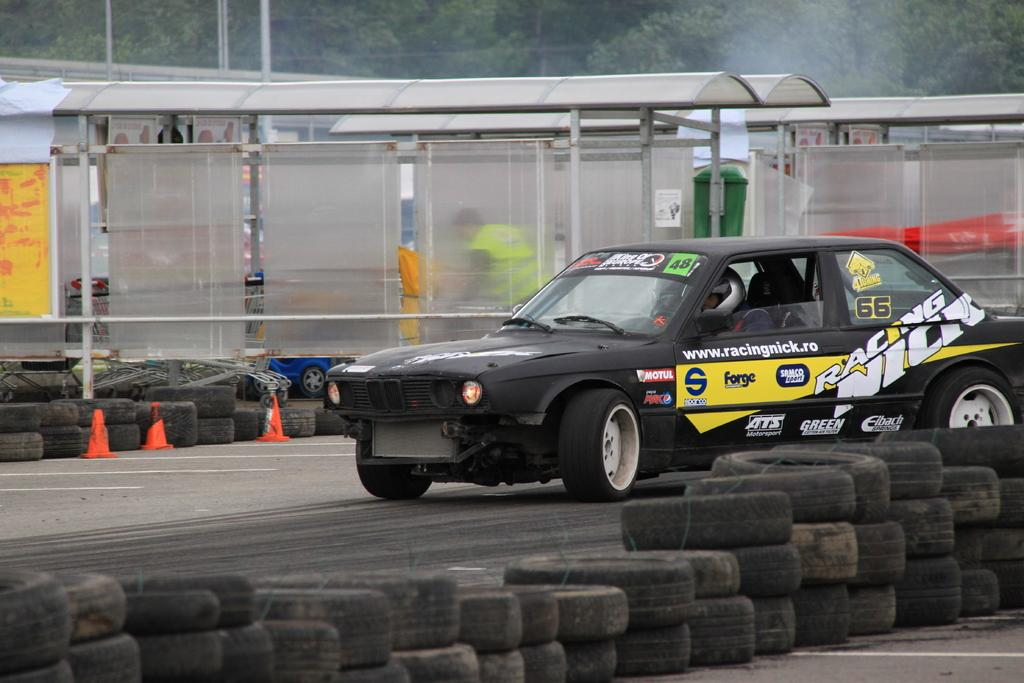What color is the car in the image? The car in the image is black. What part of the car is in contact with the ground? The car has tyres at the bottom, which are in contact with the ground. What can be seen in the background of the image? There are trees in the background of the image. What safety feature is present in the image? Safety cones are present in the image. What type of weather is depicted in the image? The image does not depict any specific weather conditions; it only shows a black car, trees in the background, and safety cones. 